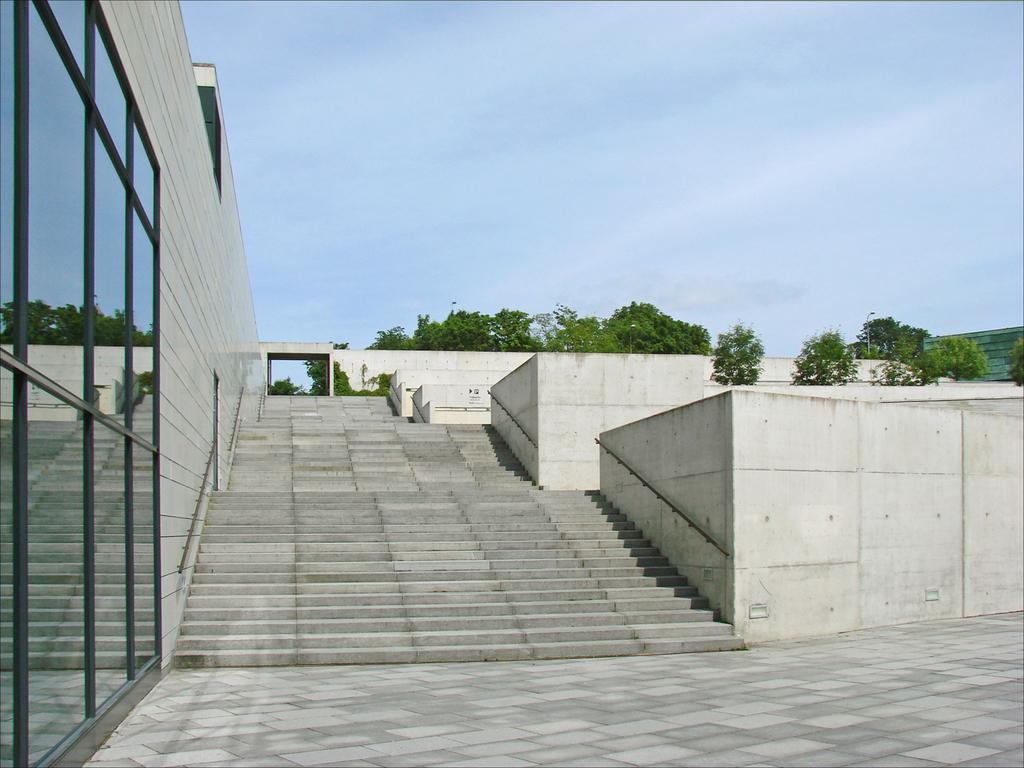What architectural feature is present in the image? There are steps in the image. What is located on the left side of the image? There is a wall and mirrors on the left side of the image. What can be seen in the background of the image? There are trees and the sky visible in the background of the image. What unit of measurement is used to determine the profit of the trees in the image? There is no mention of profit or measurement in the image, as it primarily features steps, a wall, mirrors, trees, and the sky. 